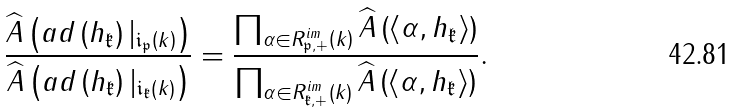Convert formula to latex. <formula><loc_0><loc_0><loc_500><loc_500>\frac { \widehat { A } \left ( a d \left ( h _ { \mathfrak k } \right ) | _ { \mathfrak i _ { \mathfrak p } \left ( k \right ) } \right ) } { \widehat { A } \left ( a d \left ( h _ { \mathfrak k } \right ) | _ { \mathfrak i _ { \mathfrak k } \left ( k \right ) } \right ) } = \frac { \prod _ { \alpha \in R ^ { i m } _ { \mathfrak p , + } \left ( k \right ) } \widehat { A } \left ( \left \langle \alpha , h _ { \mathfrak k } \right \rangle \right ) } { \prod _ { \alpha \in R ^ { i m } _ { \mathfrak k , + } \left ( k \right ) } \widehat { A } \left ( \left \langle \alpha , h _ { \mathfrak k } \right \rangle \right ) } .</formula> 